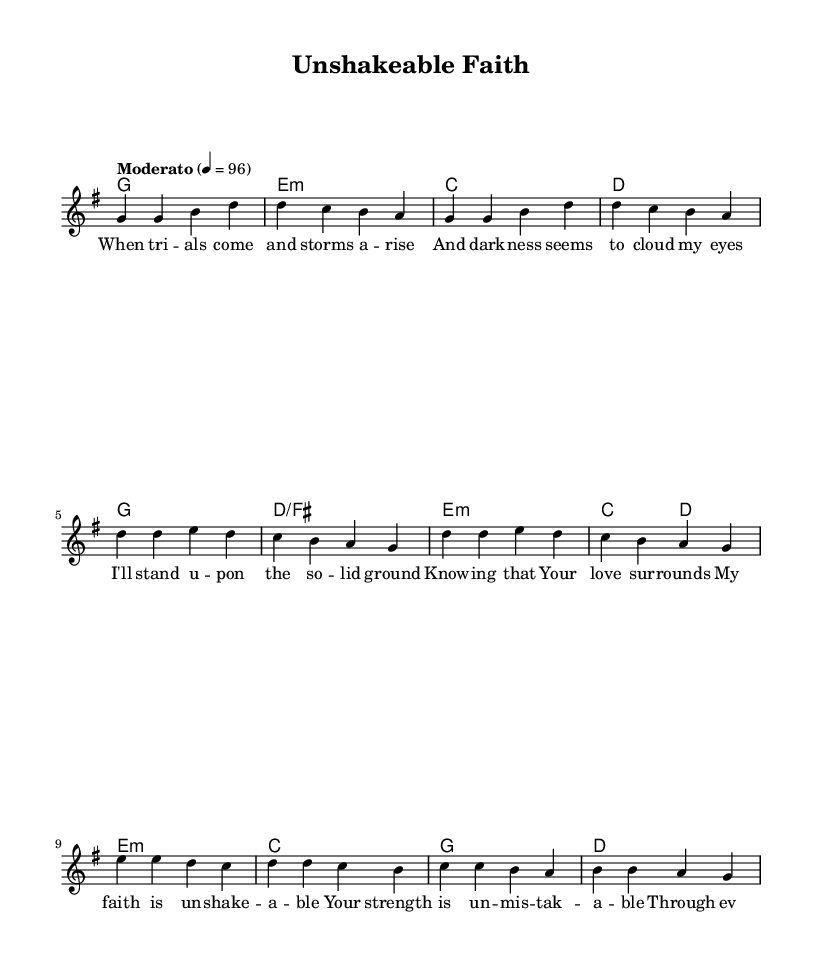What is the key signature of this music? The key signature is G major, which has one sharp (F#). This can be determined by looking at the key signature indicated at the beginning of the score, right next to the clef.
Answer: G major What is the time signature of this music? The time signature is 4/4, which indicates four beats in each measure with a quarter note getting one beat. This is indicated at the start of the score right after the key signature.
Answer: 4/4 What is the tempo marking for this piece? The tempo marking is "Moderato," which suggests a moderate pace for the piece. This marking is written above the staff in the score.
Answer: Moderato How many measures are in the verse section? There are four measures in the verse section as seen from the notation of the melody, where it consists of the first four lines of melody.
Answer: Four measures What is the main theme of the chorus lyrics? The main theme of the chorus lyrics revolves around unwavering faith and strength during challenges. This can be inferred from the key phrases within the chorus section of lyrics in the score.
Answer: Unshakeable faith What emotional state does the bridge of the song convey? The bridge conveys a sense of resilience and divine support, as it emphasizes not giving in and relying on strength through grace. This is deduced from the lyrics in the bridge section, which reflect perseverance.
Answer: Resilience How does the harmony change in the chorus compared to the verse? In the chorus, the harmony shifts to include a D/F# chord, creating a tension that resolves throughout the chorus, whereas the verse primarily centers on G, E minor, C, and D chords. This harmony evolution can be observed by comparing the chord progressions in both sections.
Answer: Includes D/F# 